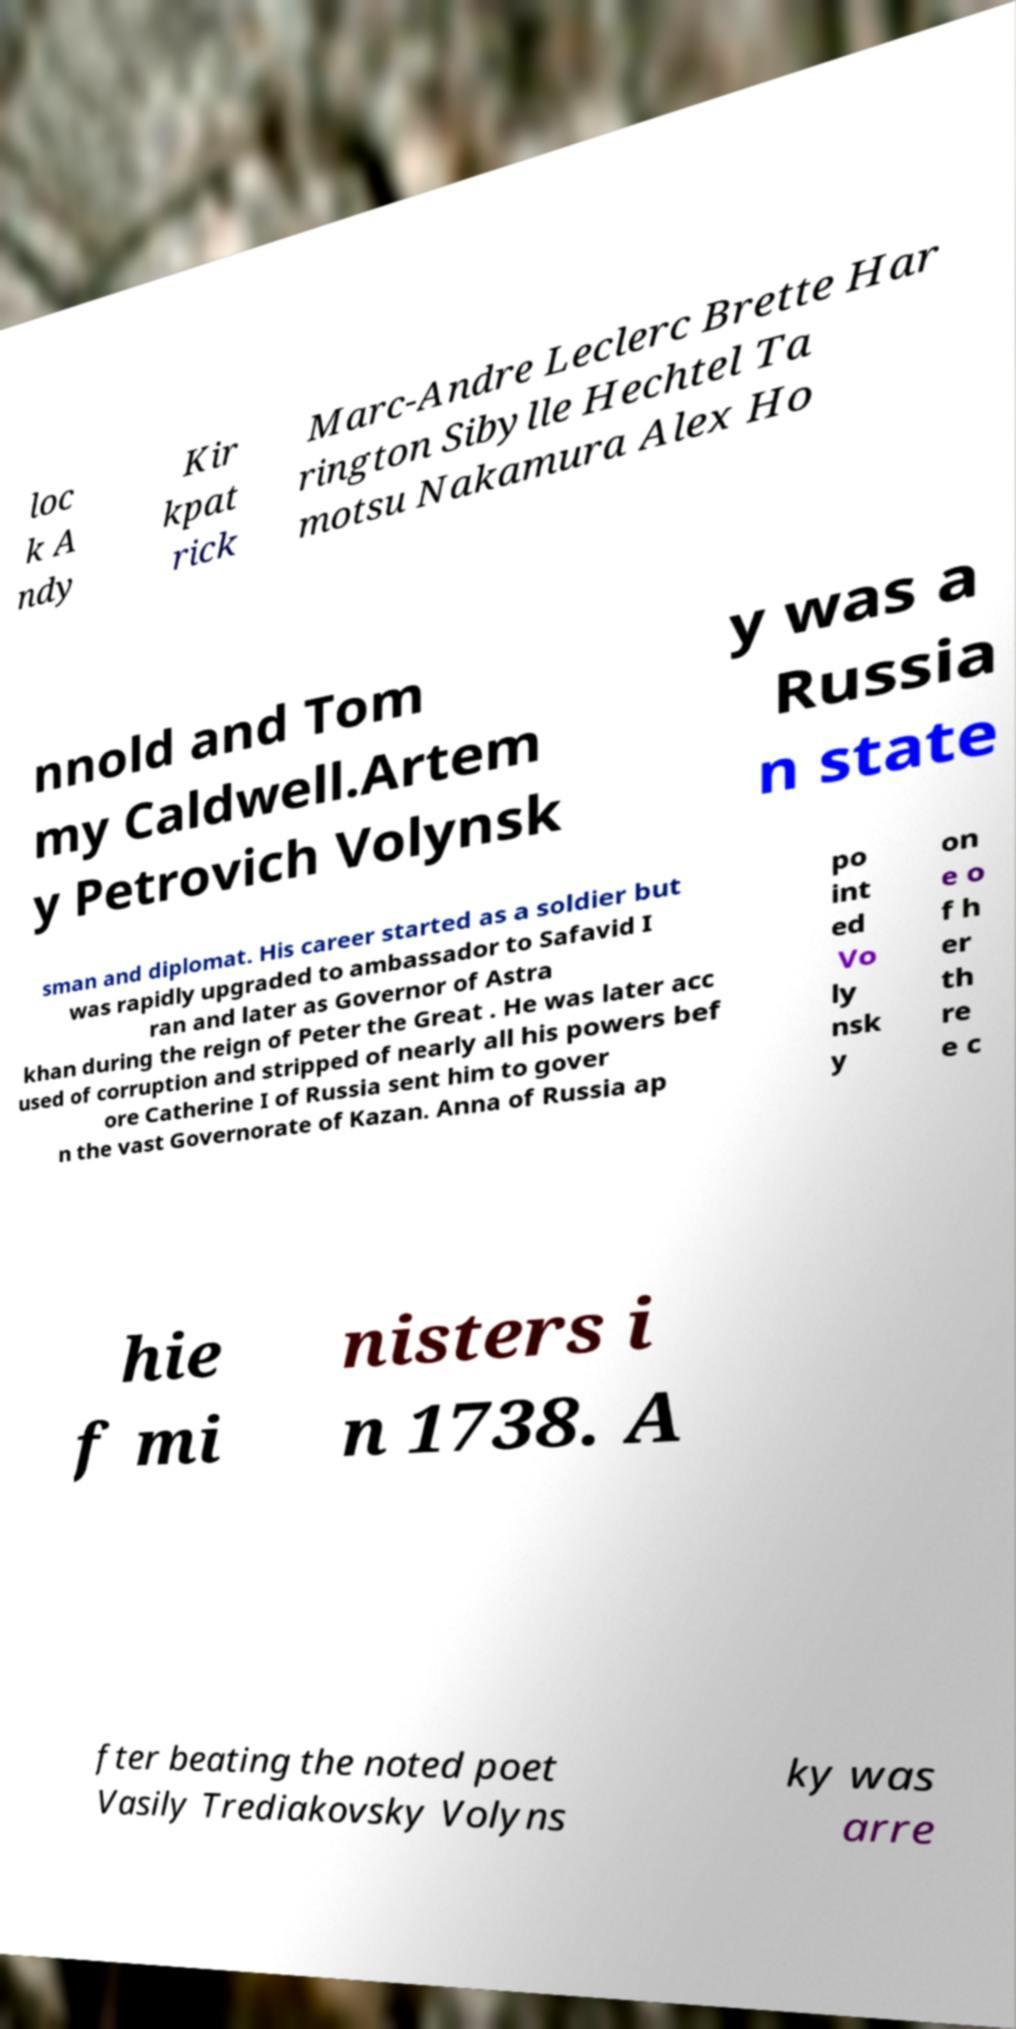There's text embedded in this image that I need extracted. Can you transcribe it verbatim? loc k A ndy Kir kpat rick Marc-Andre Leclerc Brette Har rington Sibylle Hechtel Ta motsu Nakamura Alex Ho nnold and Tom my Caldwell.Artem y Petrovich Volynsk y was a Russia n state sman and diplomat. His career started as a soldier but was rapidly upgraded to ambassador to Safavid I ran and later as Governor of Astra khan during the reign of Peter the Great . He was later acc used of corruption and stripped of nearly all his powers bef ore Catherine I of Russia sent him to gover n the vast Governorate of Kazan. Anna of Russia ap po int ed Vo ly nsk y on e o f h er th re e c hie f mi nisters i n 1738. A fter beating the noted poet Vasily Trediakovsky Volyns ky was arre 